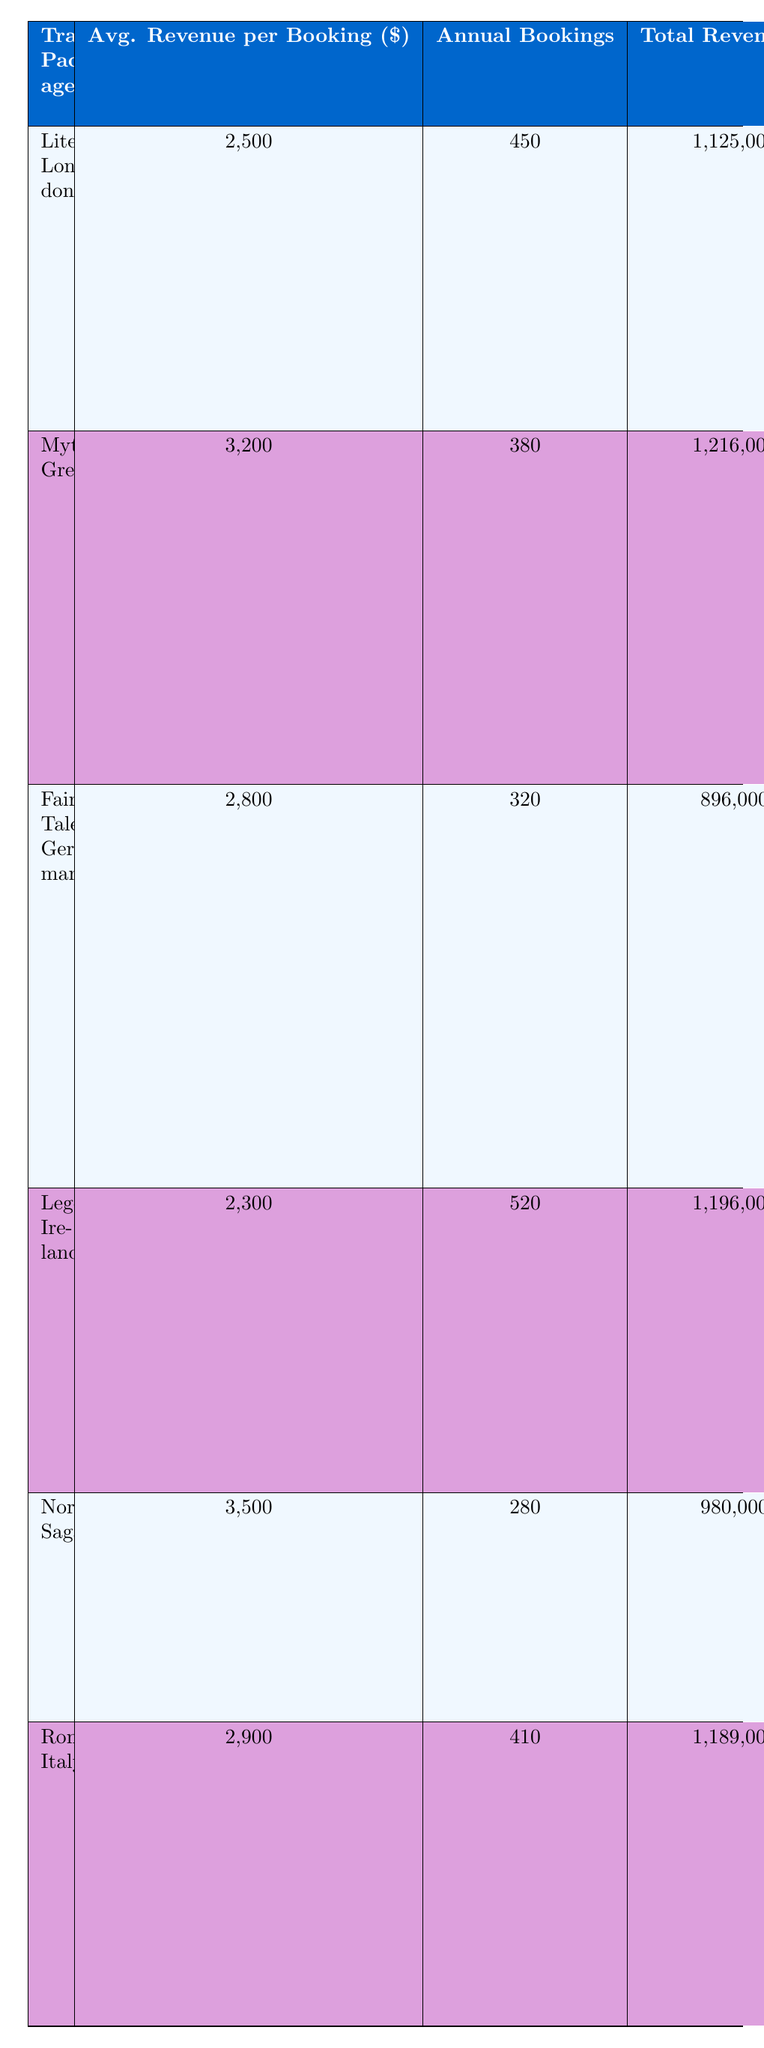What is the total revenue generated by the Mythical Greece package? The total revenue for the Mythical Greece package is listed in the table under the "Total Revenue ($)" column, which shows 1,216,000.
Answer: 1,216,000 Which travel package has the highest average revenue per booking? By comparing the "Average Revenue per Booking ($)" values, the Nordic Sagas package has the highest value at 3,500.
Answer: Nordic Sagas How many annual bookings does the Literary London package have? The number of annual bookings for the Literary London package is directly found in the "Annual Bookings" column, which indicates 450 bookings.
Answer: 450 What is the average customer satisfaction rating for all packages? To find the average customer satisfaction rating, sum the ratings (4.7 + 4.8 + 4.6 + 4.5 + 4.9 + 4.7) = 28.2, and divide by the number of packages, which is 6. Thus, 28.2 / 6 = 4.7.
Answer: 4.7 Is the total revenue from the Fairy Tale Germany package greater than 900,000? The total revenue for the Fairy Tale Germany package is 896,000, which is less than 900,000, therefore the statement is false.
Answer: No Which package combines storytelling elements about Shakespeare with guided tours? The package that includes storytelling elements related to Shakespeare is Literary London, which features guided tours of Dickens' London and Shakespeare's Globe workshop.
Answer: Literary London What is the difference in total revenue between Mythical Greece and Legendary Ireland? The total revenue for Mythical Greece is 1,216,000 and for Legendary Ireland is 1,196,000. The difference is calculated as 1,216,000 - 1,196,000 = 20,000.
Answer: 20,000 Which two packages have a customer satisfaction rating of 4.7? By reviewing the "Customer Satisfaction Rating" column, both Literary London and Romantic Italy packages have a rating of 4.7.
Answer: Literary London, Romantic Italy What storytelling elements are featured in the Nordic Sagas package? The Nordic Sagas package includes storytelling elements such as Viking history tours and Icelandic saga workshops, as listed under "Storytelling Elements."
Answer: Viking history tours, Icelandic saga workshops 